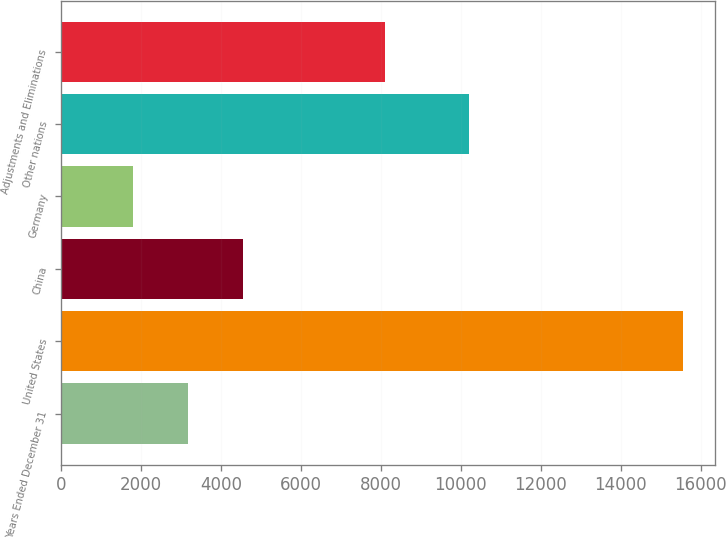Convert chart. <chart><loc_0><loc_0><loc_500><loc_500><bar_chart><fcel>Years Ended December 31<fcel>United States<fcel>China<fcel>Germany<fcel>Other nations<fcel>Adjustments and Eliminations<nl><fcel>3173.4<fcel>15570<fcel>4550.8<fcel>1796<fcel>10217<fcel>8107<nl></chart> 